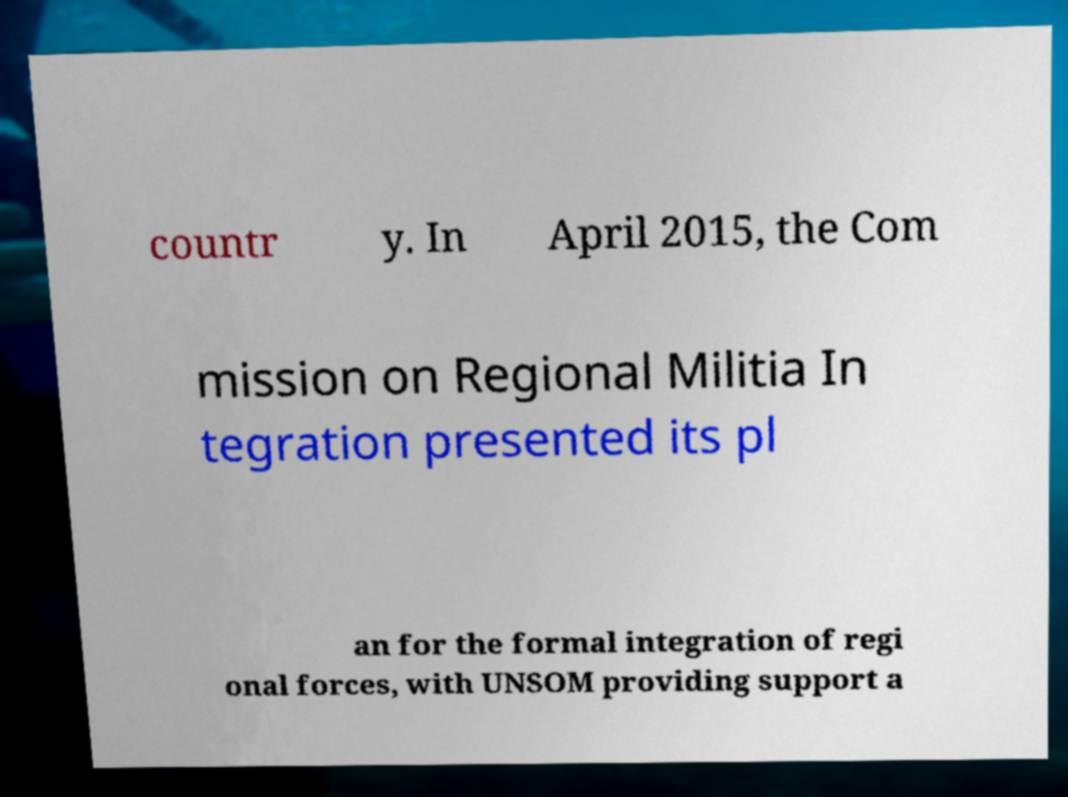Could you assist in decoding the text presented in this image and type it out clearly? countr y. In April 2015, the Com mission on Regional Militia In tegration presented its pl an for the formal integration of regi onal forces, with UNSOM providing support a 